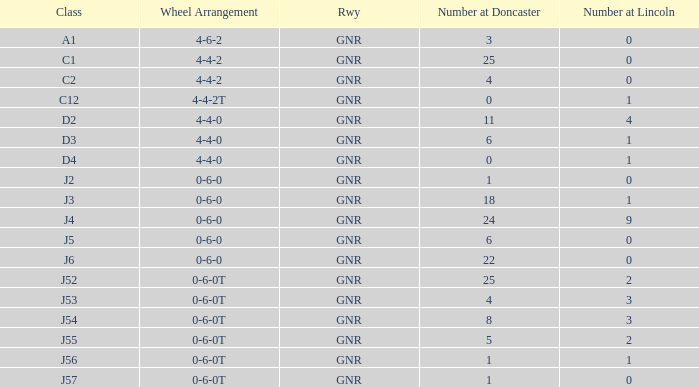Which Class has a Number at Lincoln smaller than 1 and a Wheel Arrangement of 0-6-0? J2, J5, J6. 